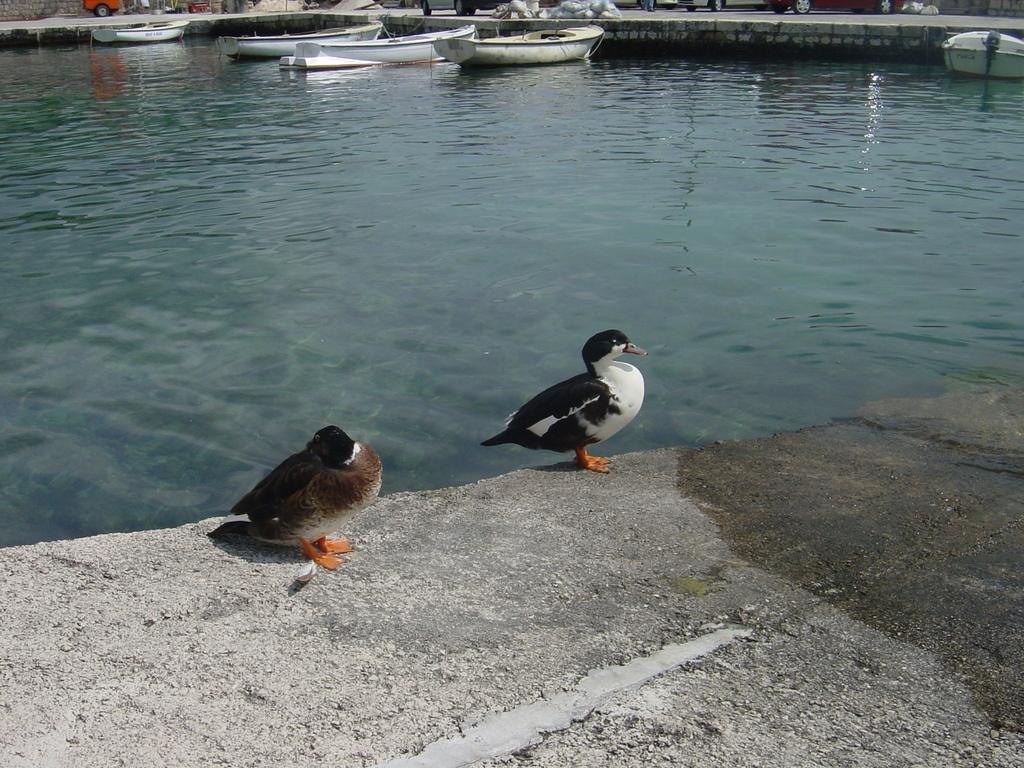What animals are on the platform in the image? There are two birds on a platform in the image. What can be seen behind the birds? There are boats in the water behind the birds. What is visible in the background of the image? There are objects on the road and vehicles visible in the background of the image. How many shoes can be seen hanging from the trees in the image? There are no shoes hanging from the trees in the image; it features two birds on a platform, boats in the water, and objects on the road in the background. 